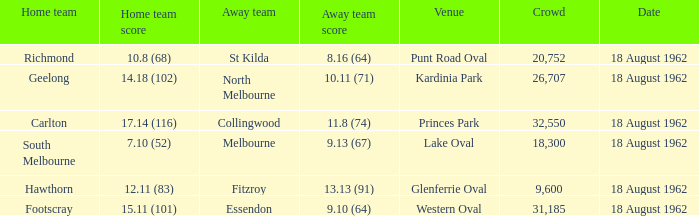What was the home team that scored 10.8 (68)? Richmond. 